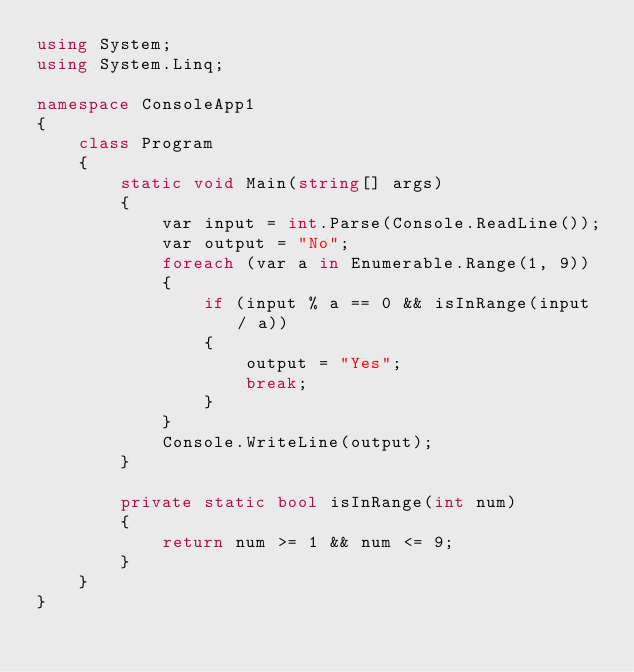Convert code to text. <code><loc_0><loc_0><loc_500><loc_500><_C#_>using System;
using System.Linq;

namespace ConsoleApp1
{
    class Program
    {
        static void Main(string[] args)
        {
            var input = int.Parse(Console.ReadLine());
            var output = "No";
            foreach (var a in Enumerable.Range(1, 9))
            {
                if (input % a == 0 && isInRange(input / a))
                {
                    output = "Yes";
                    break;
                }
            }
            Console.WriteLine(output);
        }

        private static bool isInRange(int num)
        {
            return num >= 1 && num <= 9;
        }
    }
}
</code> 